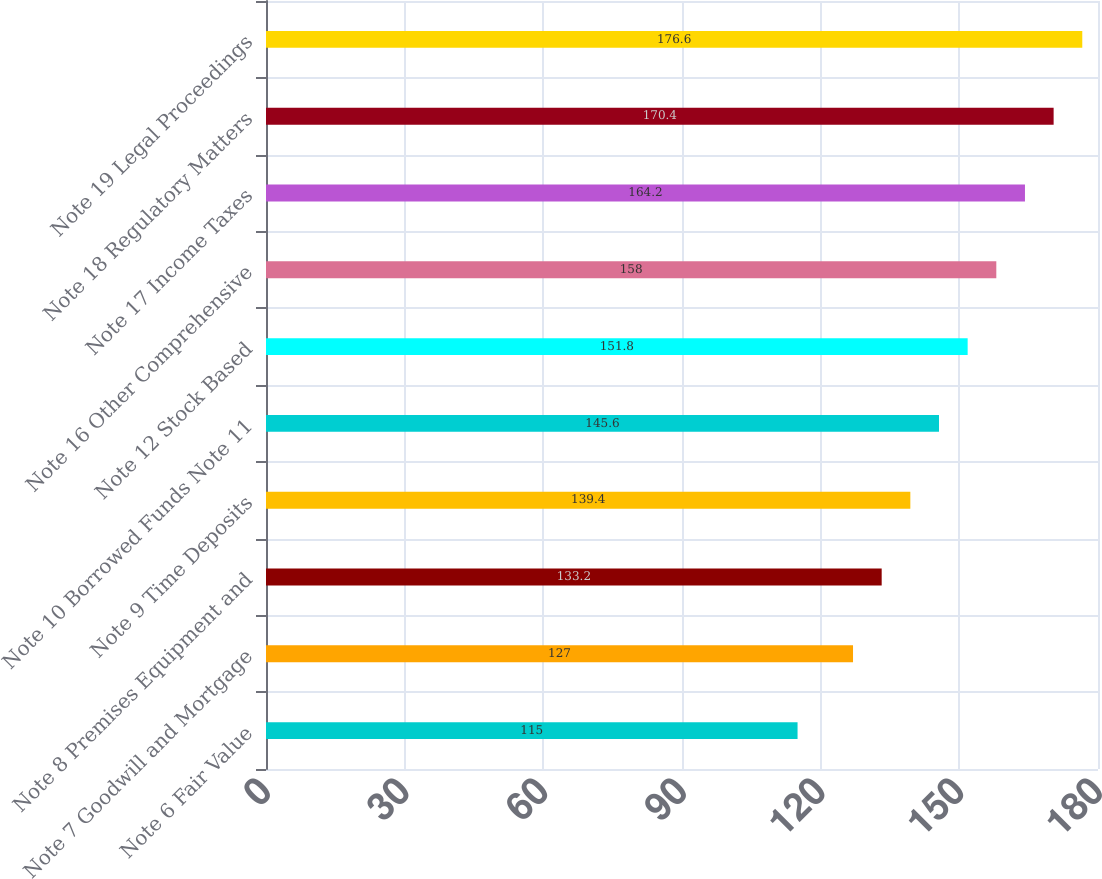<chart> <loc_0><loc_0><loc_500><loc_500><bar_chart><fcel>Note 6 Fair Value<fcel>Note 7 Goodwill and Mortgage<fcel>Note 8 Premises Equipment and<fcel>Note 9 Time Deposits<fcel>Note 10 Borrowed Funds Note 11<fcel>Note 12 Stock Based<fcel>Note 16 Other Comprehensive<fcel>Note 17 Income Taxes<fcel>Note 18 Regulatory Matters<fcel>Note 19 Legal Proceedings<nl><fcel>115<fcel>127<fcel>133.2<fcel>139.4<fcel>145.6<fcel>151.8<fcel>158<fcel>164.2<fcel>170.4<fcel>176.6<nl></chart> 